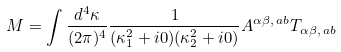Convert formula to latex. <formula><loc_0><loc_0><loc_500><loc_500>M = \int \frac { d ^ { 4 } \kappa } { ( 2 \pi ) ^ { 4 } } \frac { 1 } { ( \kappa _ { 1 } ^ { 2 } + i 0 ) ( \kappa _ { 2 } ^ { 2 } + i 0 ) } A ^ { \alpha \beta , \, a b } T _ { \alpha \beta , \, a b }</formula> 